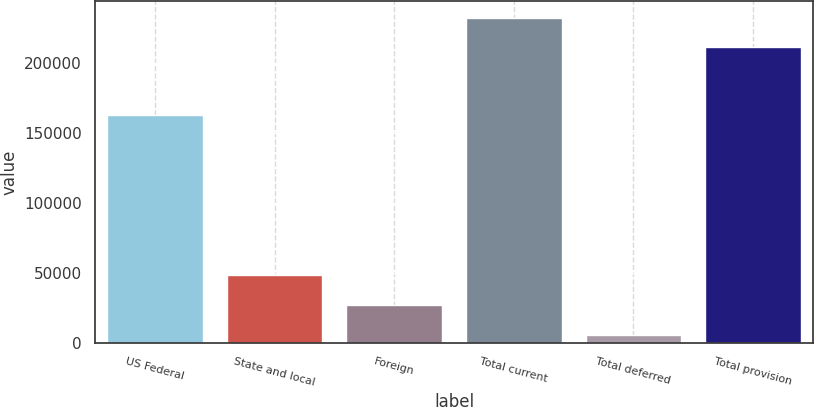<chart> <loc_0><loc_0><loc_500><loc_500><bar_chart><fcel>US Federal<fcel>State and local<fcel>Foreign<fcel>Total current<fcel>Total deferred<fcel>Total provision<nl><fcel>162948<fcel>48519.2<fcel>27380.1<fcel>232530<fcel>6241<fcel>211391<nl></chart> 